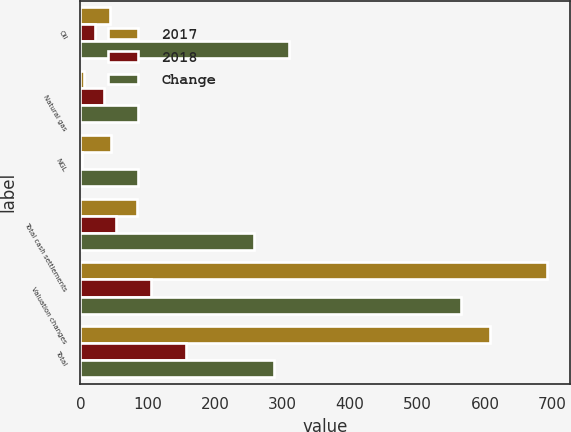<chart> <loc_0><loc_0><loc_500><loc_500><stacked_bar_chart><ecel><fcel>Oil<fcel>Natural gas<fcel>NGL<fcel>Total cash settlements<fcel>Valuation changes<fcel>Total<nl><fcel>2017<fcel>44<fcel>5<fcel>45<fcel>84<fcel>692<fcel>608<nl><fcel>2018<fcel>21<fcel>35<fcel>3<fcel>53<fcel>104<fcel>157<nl><fcel>Change<fcel>310<fcel>86<fcel>86<fcel>258<fcel>565<fcel>287<nl></chart> 